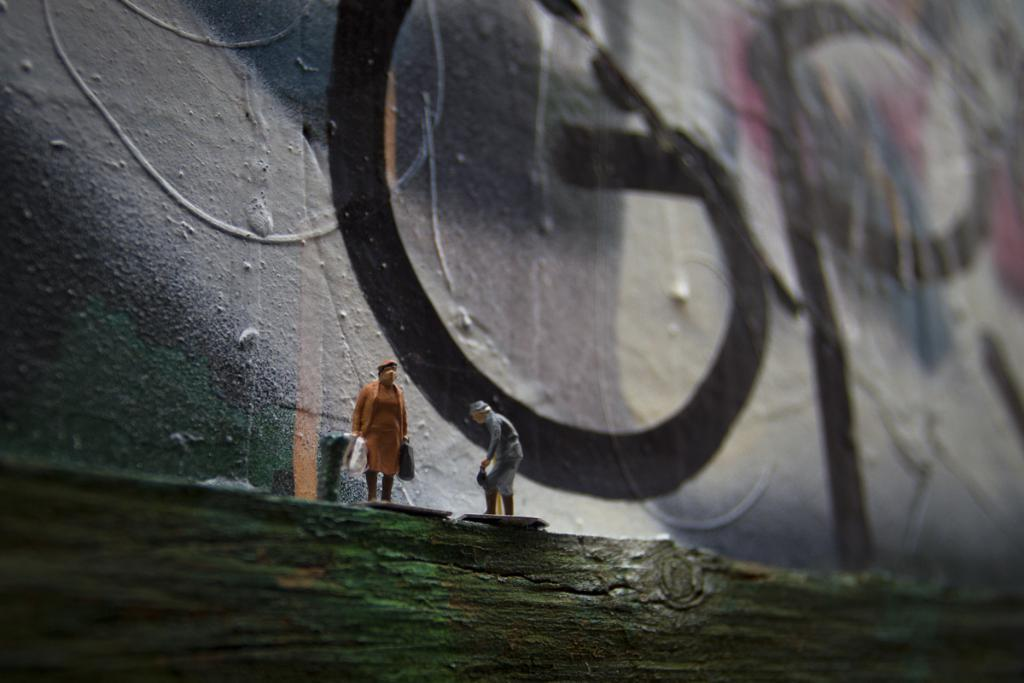What can be seen on the wooden object in the image? There are miniatures of people on a wooden object in the image. How would you describe the overall appearance of the image? The background of the image is blurry. What can be seen in the distance in the image? There is a wall visible in the background of the image. How many clovers are present on the wooden object in the image? There are no clovers present on the wooden object in the image. What type of card is being used by the miniature people in the image? There are no cards visible in the image; the miniatures are on a wooden object. 